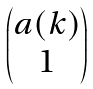Convert formula to latex. <formula><loc_0><loc_0><loc_500><loc_500>\begin{pmatrix} a ( k ) \\ 1 \end{pmatrix}</formula> 